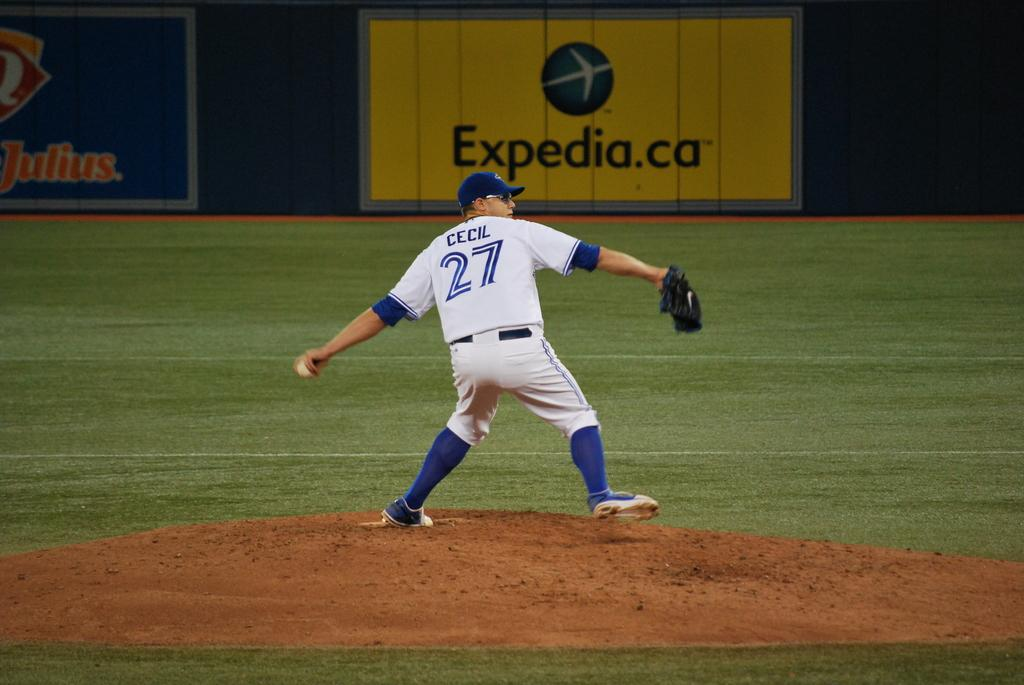<image>
Write a terse but informative summary of the picture. the number 27 is on the back of a jersey 